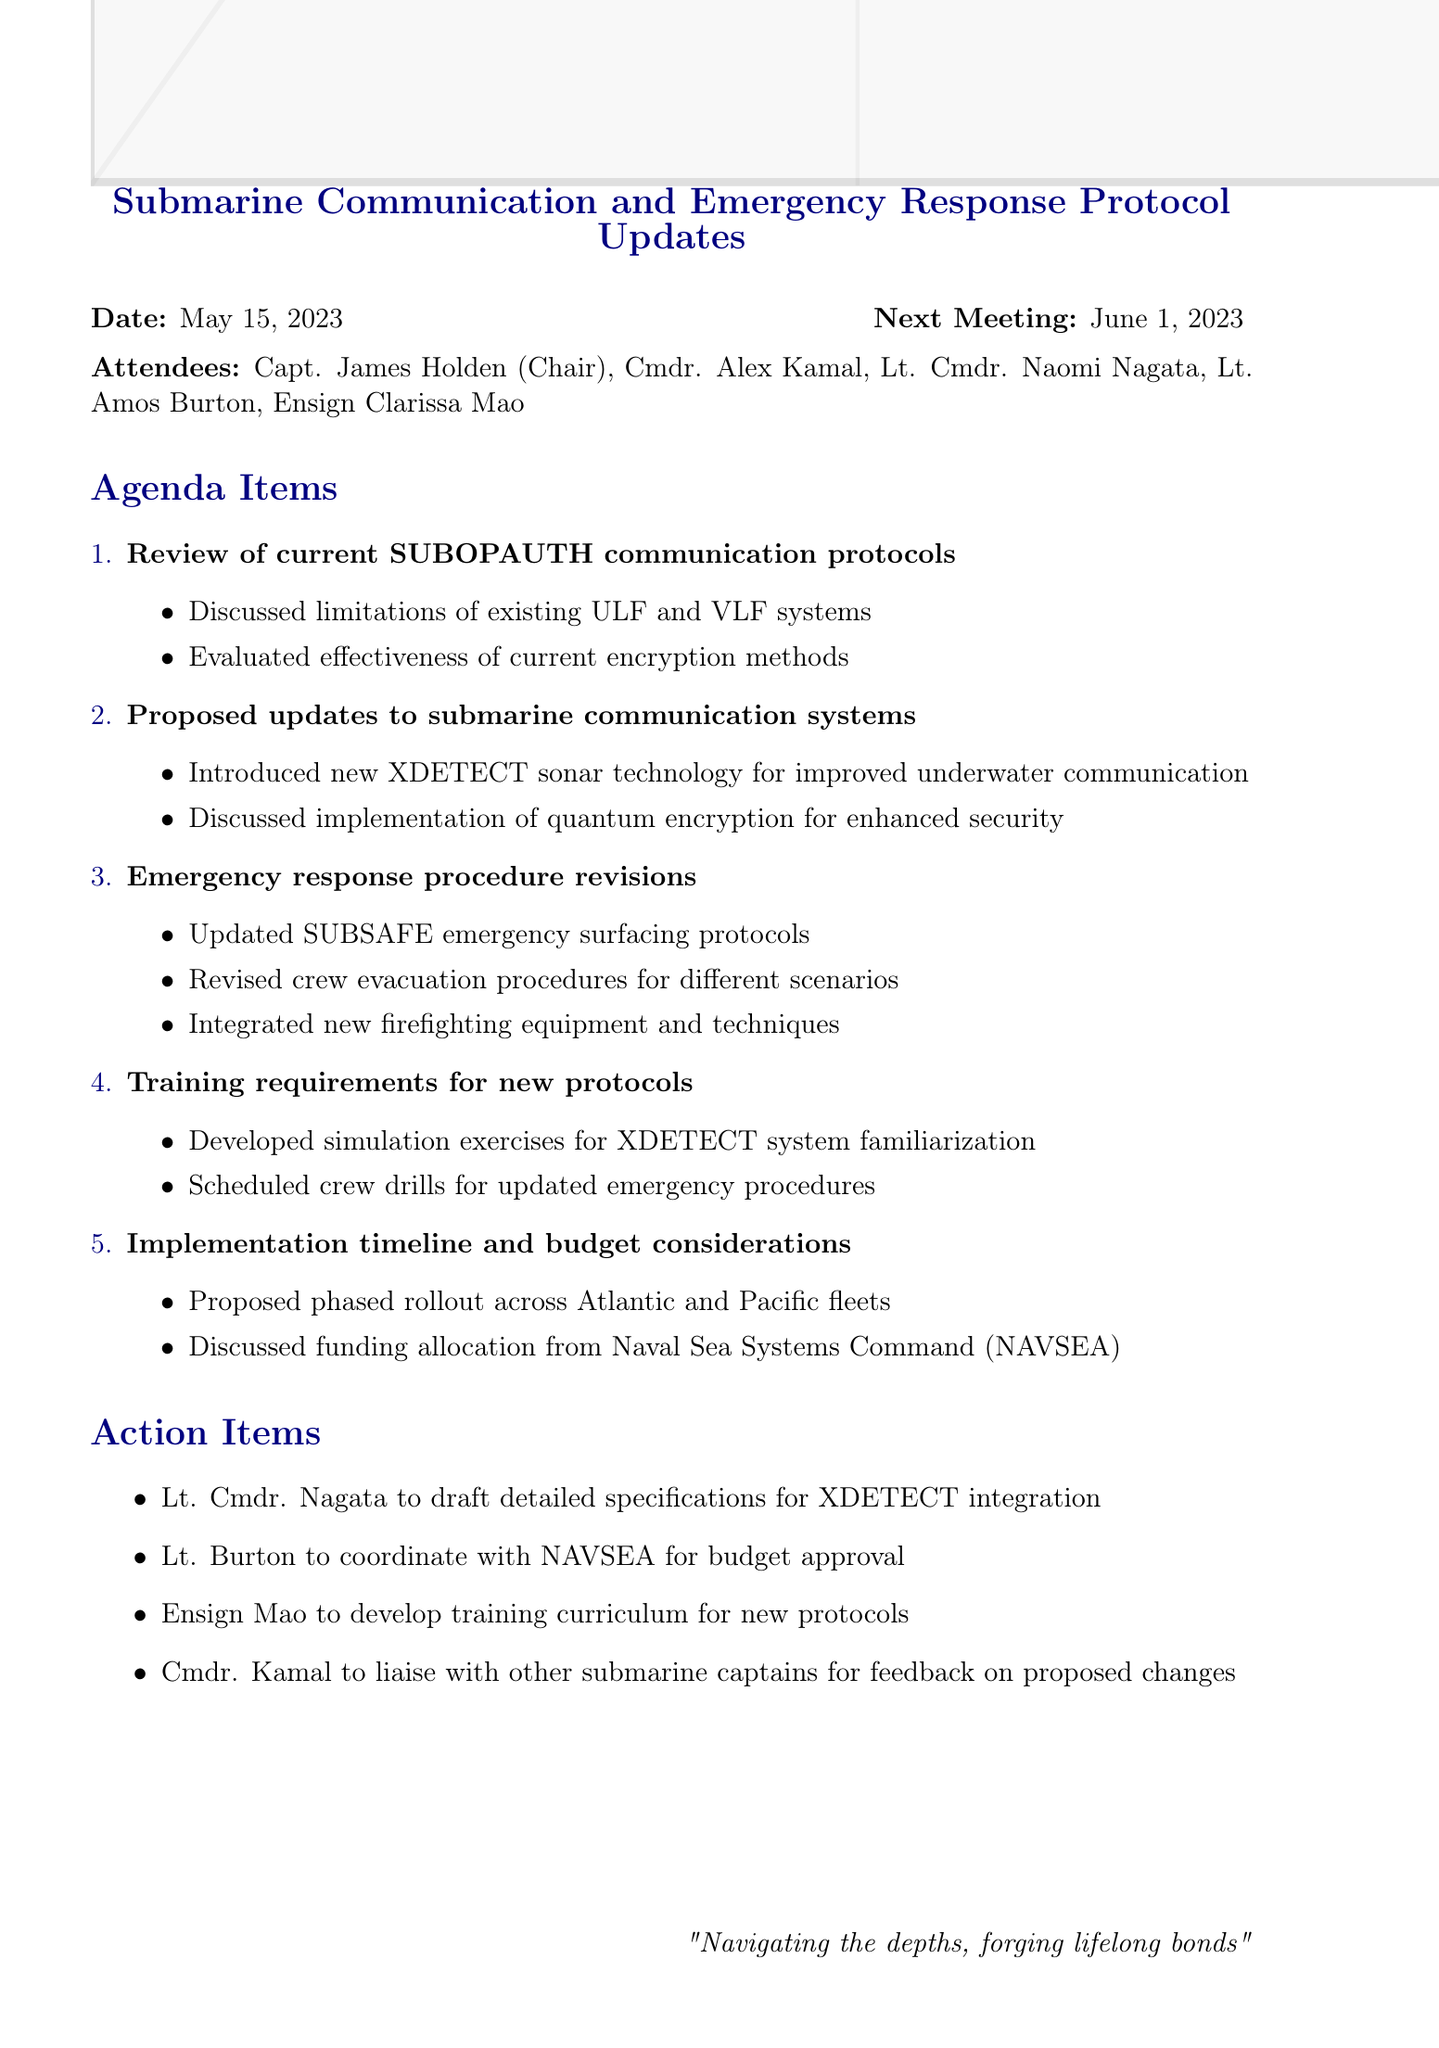What is the meeting title? The meeting title is stated clearly at the top of the document, identifying the main focus of the meeting.
Answer: Submarine Communication and Emergency Response Protocol Updates Who chaired the meeting? The name of the chairperson is mentioned in the list of attendees at the beginning of the document.
Answer: Capt. James Holden What is one proposed communication technology discussed? One of the agenda items specifically focuses on proposed updates to submarine communication systems.
Answer: XDETECT sonar technology What is the date of the next meeting? The next meeting date is provided at the end of the date section of the document.
Answer: June 1, 2023 Which officer is tasked with drafting specifications for XDETECT integration? Action items list the responsibilities assigned to different officers after discussing the agenda.
Answer: Lt. Cmdr. Nagata How many agenda items were discussed in total? The document lists each agenda item under the section for agenda items.
Answer: 5 What is an example of a revised emergency procedure? The key points under emergency response procedures provide specific updates that were discussed.
Answer: Crew evacuation procedures Who is responsible for developing the training curriculum? The action items section outlines specific responsibilities assigned to various members after the meeting.
Answer: Ensign Mao What new technique is integrated into the emergency response procedures? The agenda for emergency response procedure revisions mentions the addition of new techniques and equipment.
Answer: Firefighting techniques 